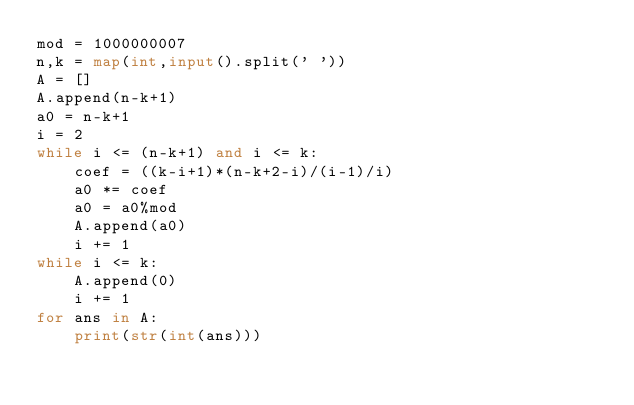<code> <loc_0><loc_0><loc_500><loc_500><_Python_>mod = 1000000007
n,k = map(int,input().split(' '))
A = []
A.append(n-k+1)
a0 = n-k+1
i = 2
while i <= (n-k+1) and i <= k:
    coef = ((k-i+1)*(n-k+2-i)/(i-1)/i)
    a0 *= coef
    a0 = a0%mod
    A.append(a0)
    i += 1
while i <= k:
    A.append(0)
    i += 1
for ans in A:
    print(str(int(ans)))</code> 